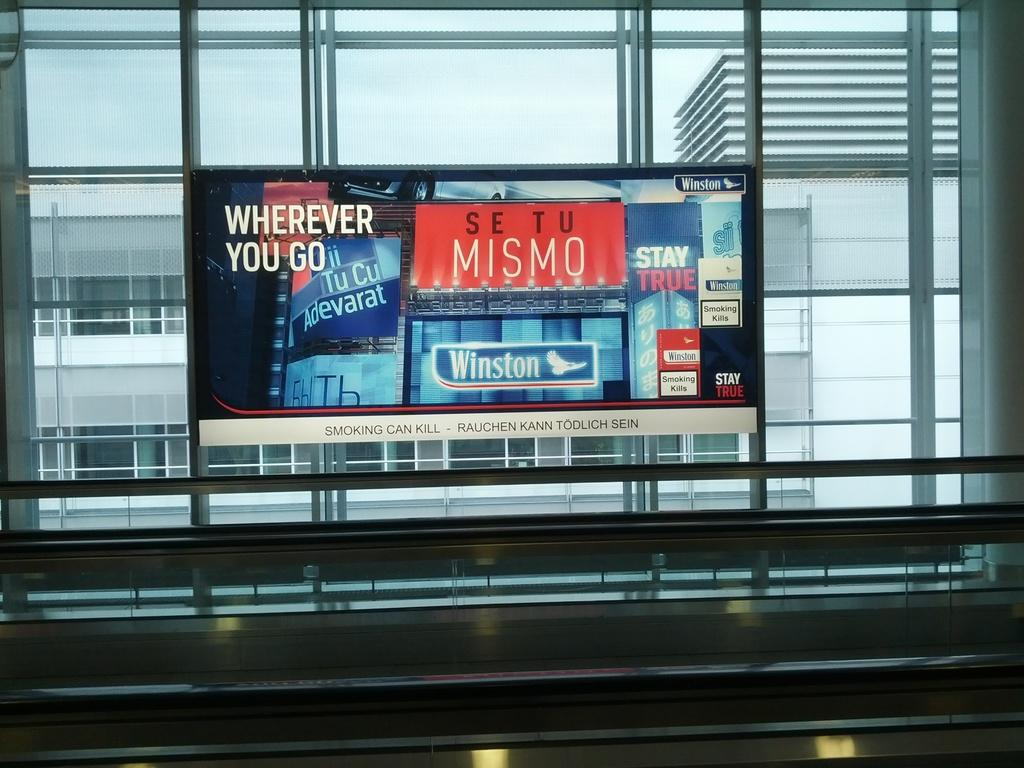<image>
Write a terse but informative summary of the picture. some ads on a window that say WHEREEVER YOU GO, MISMO and Winston. 